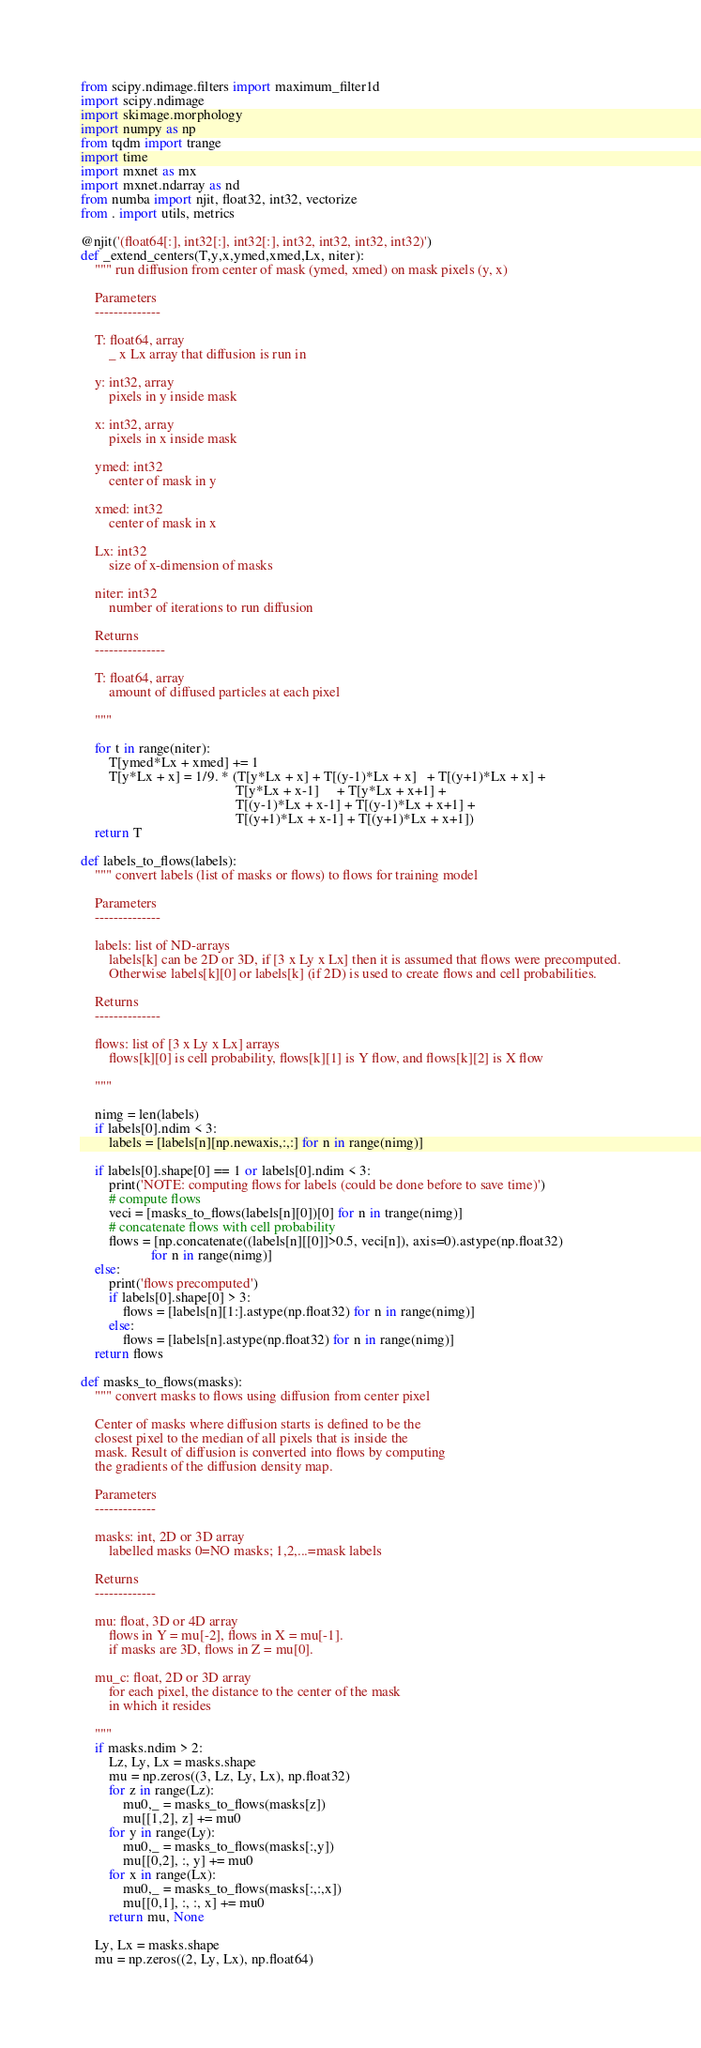<code> <loc_0><loc_0><loc_500><loc_500><_Python_>from scipy.ndimage.filters import maximum_filter1d
import scipy.ndimage
import skimage.morphology
import numpy as np
from tqdm import trange
import time
import mxnet as mx
import mxnet.ndarray as nd
from numba import njit, float32, int32, vectorize
from . import utils, metrics

@njit('(float64[:], int32[:], int32[:], int32, int32, int32, int32)')
def _extend_centers(T,y,x,ymed,xmed,Lx, niter):
    """ run diffusion from center of mask (ymed, xmed) on mask pixels (y, x)

    Parameters
    --------------

    T: float64, array
        _ x Lx array that diffusion is run in

    y: int32, array
        pixels in y inside mask

    x: int32, array
        pixels in x inside mask

    ymed: int32
        center of mask in y

    xmed: int32
        center of mask in x

    Lx: int32
        size of x-dimension of masks

    niter: int32
        number of iterations to run diffusion

    Returns
    ---------------

    T: float64, array
        amount of diffused particles at each pixel

    """

    for t in range(niter):
        T[ymed*Lx + xmed] += 1
        T[y*Lx + x] = 1/9. * (T[y*Lx + x] + T[(y-1)*Lx + x]   + T[(y+1)*Lx + x] +
                                            T[y*Lx + x-1]     + T[y*Lx + x+1] +
                                            T[(y-1)*Lx + x-1] + T[(y-1)*Lx + x+1] +
                                            T[(y+1)*Lx + x-1] + T[(y+1)*Lx + x+1])
    return T

def labels_to_flows(labels):
    """ convert labels (list of masks or flows) to flows for training model 

    Parameters
    --------------

    labels: list of ND-arrays
        labels[k] can be 2D or 3D, if [3 x Ly x Lx] then it is assumed that flows were precomputed.
        Otherwise labels[k][0] or labels[k] (if 2D) is used to create flows and cell probabilities.

    Returns
    --------------

    flows: list of [3 x Ly x Lx] arrays
        flows[k][0] is cell probability, flows[k][1] is Y flow, and flows[k][2] is X flow

    """

    nimg = len(labels)
    if labels[0].ndim < 3:
        labels = [labels[n][np.newaxis,:,:] for n in range(nimg)]

    if labels[0].shape[0] == 1 or labels[0].ndim < 3:
        print('NOTE: computing flows for labels (could be done before to save time)')
        # compute flows        
        veci = [masks_to_flows(labels[n][0])[0] for n in trange(nimg)]
        # concatenate flows with cell probability
        flows = [np.concatenate((labels[n][[0]]>0.5, veci[n]), axis=0).astype(np.float32)
                    for n in range(nimg)]
    else:
        print('flows precomputed')
        if labels[0].shape[0] > 3:
            flows = [labels[n][1:].astype(np.float32) for n in range(nimg)]
        else:
            flows = [labels[n].astype(np.float32) for n in range(nimg)]
    return flows

def masks_to_flows(masks):
    """ convert masks to flows using diffusion from center pixel

    Center of masks where diffusion starts is defined to be the 
    closest pixel to the median of all pixels that is inside the 
    mask. Result of diffusion is converted into flows by computing
    the gradients of the diffusion density map. 

    Parameters
    -------------

    masks: int, 2D or 3D array
        labelled masks 0=NO masks; 1,2,...=mask labels

    Returns
    -------------

    mu: float, 3D or 4D array 
        flows in Y = mu[-2], flows in X = mu[-1].
        if masks are 3D, flows in Z = mu[0].

    mu_c: float, 2D or 3D array
        for each pixel, the distance to the center of the mask 
        in which it resides 

    """
    if masks.ndim > 2:
        Lz, Ly, Lx = masks.shape
        mu = np.zeros((3, Lz, Ly, Lx), np.float32)
        for z in range(Lz):
            mu0,_ = masks_to_flows(masks[z])
            mu[[1,2], z] += mu0
        for y in range(Ly):
            mu0,_ = masks_to_flows(masks[:,y])
            mu[[0,2], :, y] += mu0
        for x in range(Lx):
            mu0,_ = masks_to_flows(masks[:,:,x])
            mu[[0,1], :, :, x] += mu0
        return mu, None

    Ly, Lx = masks.shape
    mu = np.zeros((2, Ly, Lx), np.float64)</code> 